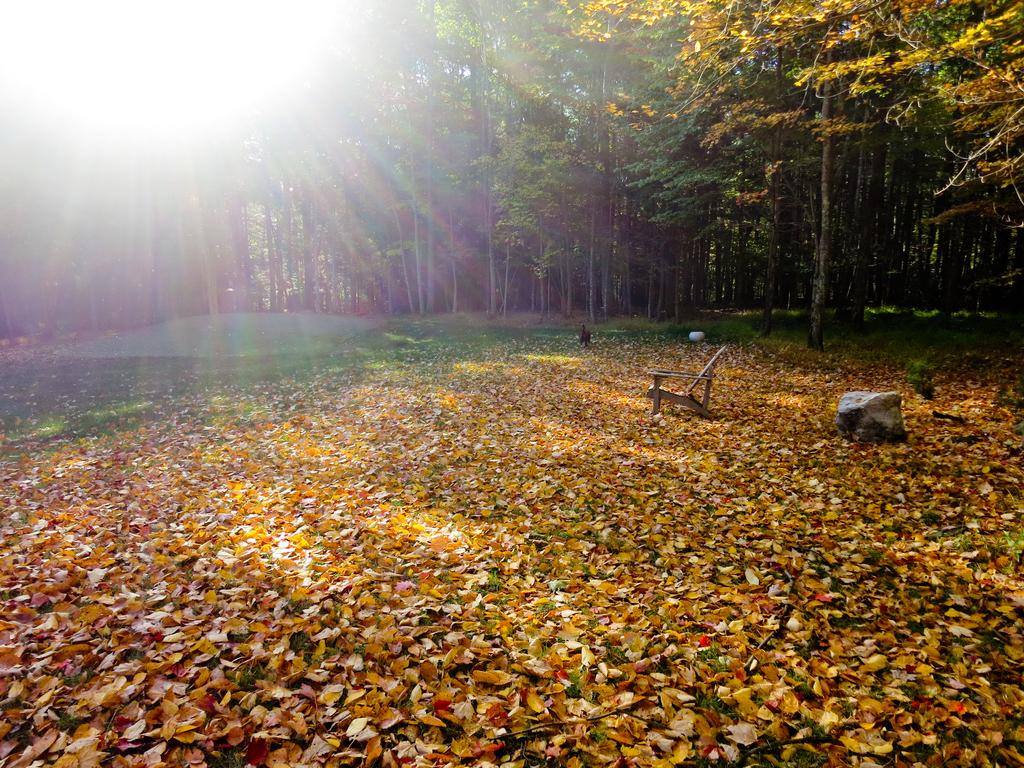What type of natural elements can be seen in the image? There are trees in the image. What is the source of light in the image? Sunlight is visible in the image. What object is located at the bottom of the image? There is a chair, a bird, and a rock at the bottom of the image. What is present on the ground in the image? There are leaves on the ground in the image. What type of leather material is used to make the throne in the image? There is no throne present in the image; it features trees, sunlight, a chair, a bird, a rock, and leaves on the ground. 